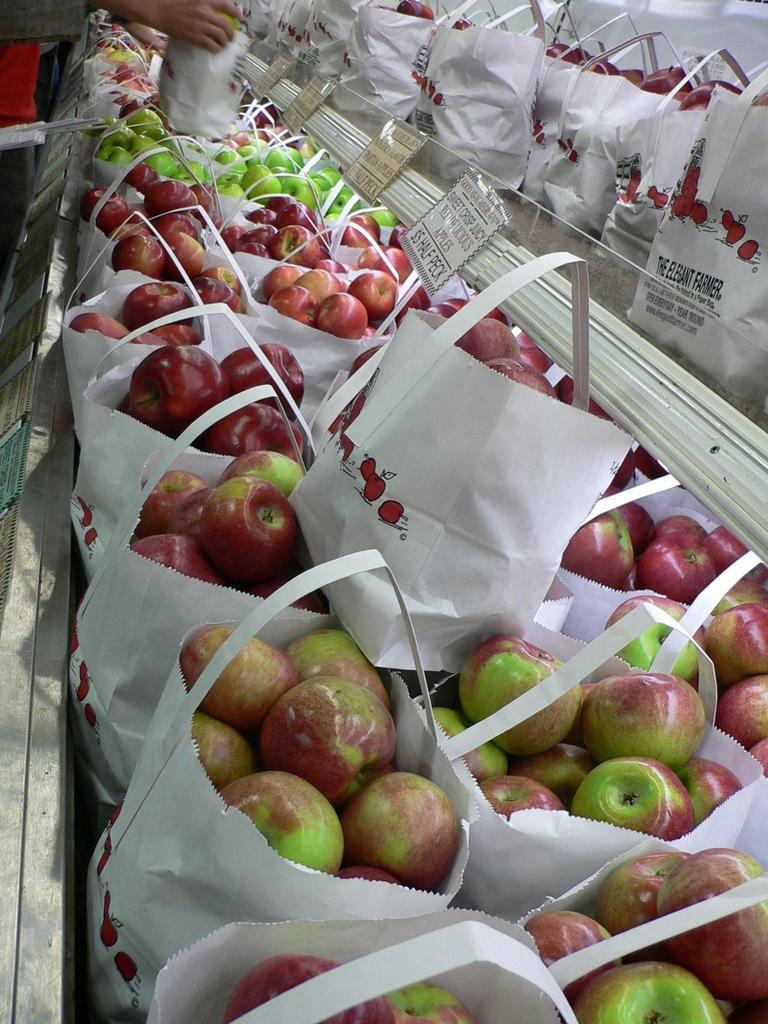Could you give a brief overview of what you see in this image? In this image, we can see paper bags with apples in it. The apples are red and green in color. There are tags with some text written on it and we can even see the hands of a person who is holding a paper bag with apples in it. 